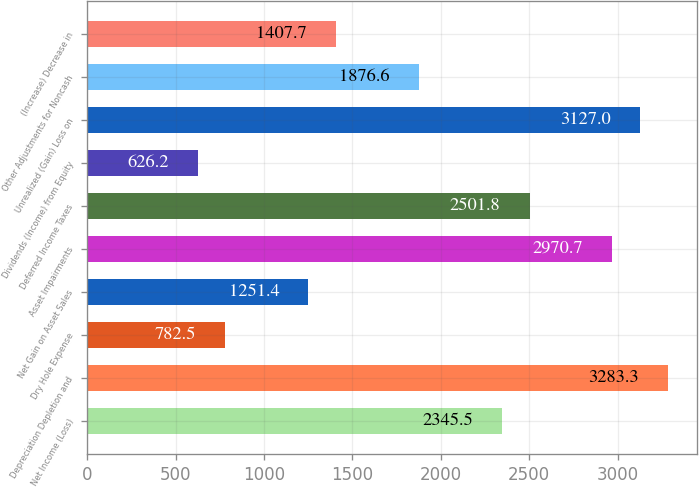Convert chart. <chart><loc_0><loc_0><loc_500><loc_500><bar_chart><fcel>Net Income (Loss)<fcel>Depreciation Depletion and<fcel>Dry Hole Expense<fcel>Net Gain on Asset Sales<fcel>Asset Impairments<fcel>Deferred Income Taxes<fcel>Dividends (Income) from Equity<fcel>Unrealized (Gain) Loss on<fcel>Other Adjustments for Noncash<fcel>(Increase) Decrease in<nl><fcel>2345.5<fcel>3283.3<fcel>782.5<fcel>1251.4<fcel>2970.7<fcel>2501.8<fcel>626.2<fcel>3127<fcel>1876.6<fcel>1407.7<nl></chart> 